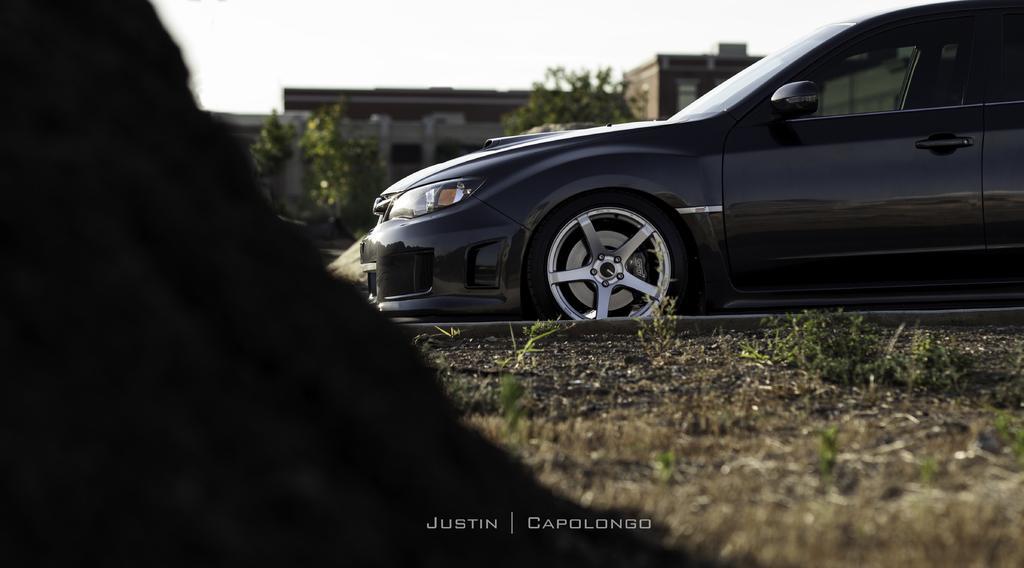How would you summarize this image in a sentence or two? In this image I can see a black colored object to the left side of the image and to the right side of the image I can see a car which is black in color on the ground. In the background I can see few trees, a building and the sky. 